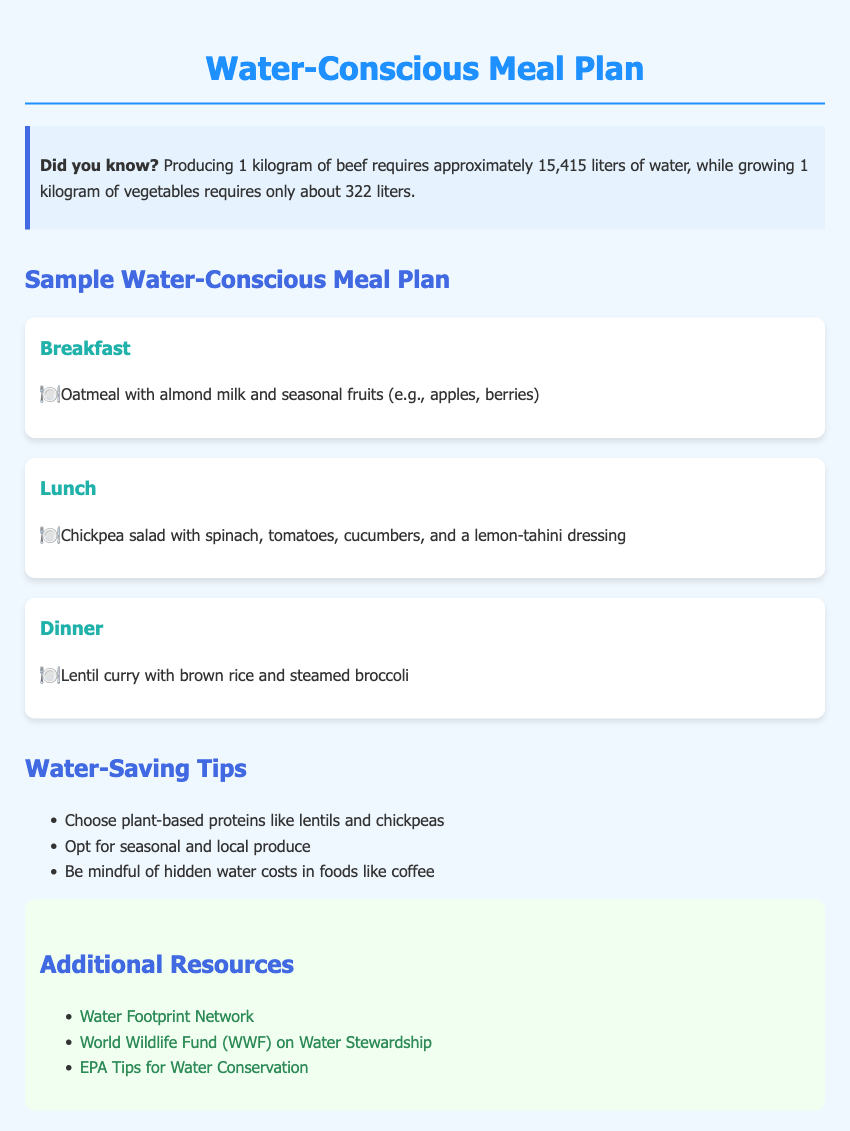What is the total water required to produce 1 kilogram of beef? The document states that producing 1 kilogram of beef requires approximately 15,415 liters of water.
Answer: 15,415 liters What is the main ingredient in the breakfast meal? The breakfast meal consists of oatmeal with almond milk and seasonal fruits.
Answer: Oatmeal Which legumes are suggested as plant-based proteins in water-saving tips? The document mentions lentils and chickpeas as choices for plant-based proteins.
Answer: Lentils and chickpeas What type of dressing is included in the lunch meal? The lunch meal features a lemon-tahini dressing.
Answer: Lemon-tahini How many meals are included in the sample meal plan? There are three meals listed in the meal plan: breakfast, lunch, and dinner.
Answer: Three meals What is the main carbohydrate source in the dinner meal? The dinner meal includes brown rice as the main carbohydrate source.
Answer: Brown rice Which organization is linked for additional water conservation resources? One of the additional resources is the Water Footprint Network.
Answer: Water Footprint Network What color is associated with the heading for additional resources? The heading for additional resources is associated with a green color (#2e8b57).
Answer: Green What type of cuisine is featured in the dinner meal? The dinner meal is a lentil curry, indicating a vegetarian or plant-based cuisine.
Answer: Vegetarian or plant-based cuisine 